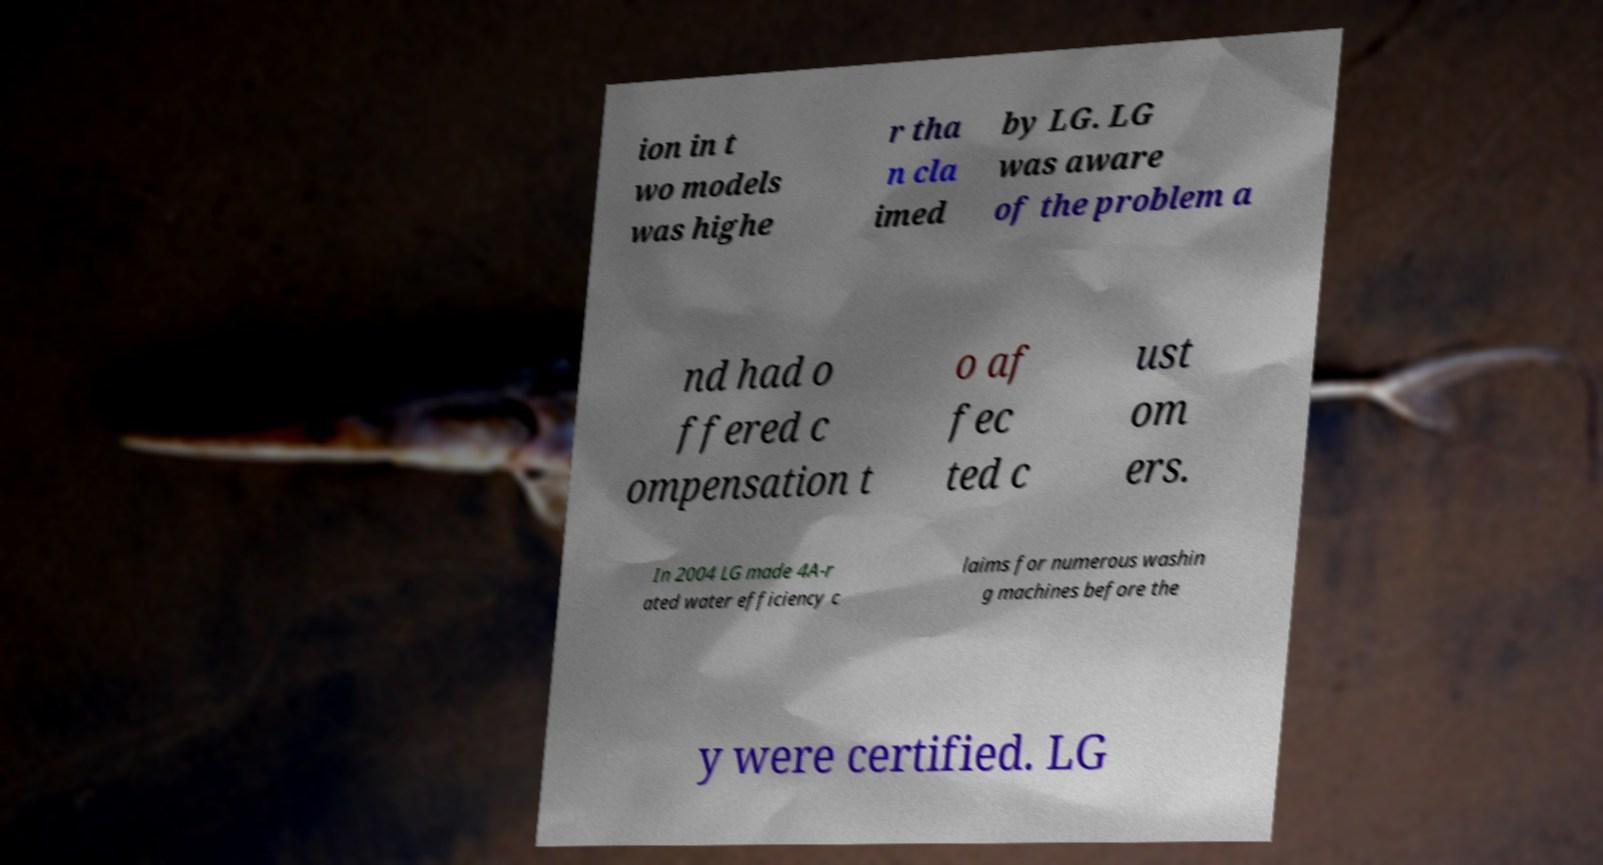Could you extract and type out the text from this image? ion in t wo models was highe r tha n cla imed by LG. LG was aware of the problem a nd had o ffered c ompensation t o af fec ted c ust om ers. In 2004 LG made 4A-r ated water efficiency c laims for numerous washin g machines before the y were certified. LG 